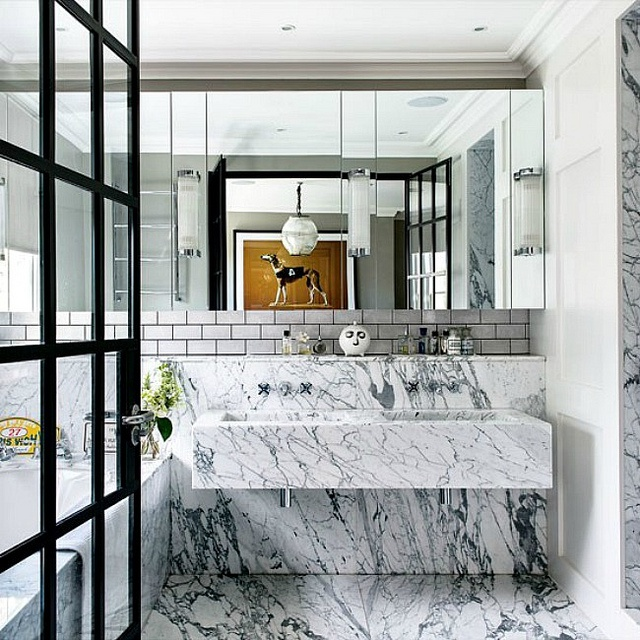Describe the objects in this image and their specific colors. I can see sink in lightgray and darkgray tones, sink in lightgray and darkgray tones, dog in lightgray, black, olive, maroon, and tan tones, and sink in lightgray, darkgray, and gray tones in this image. 